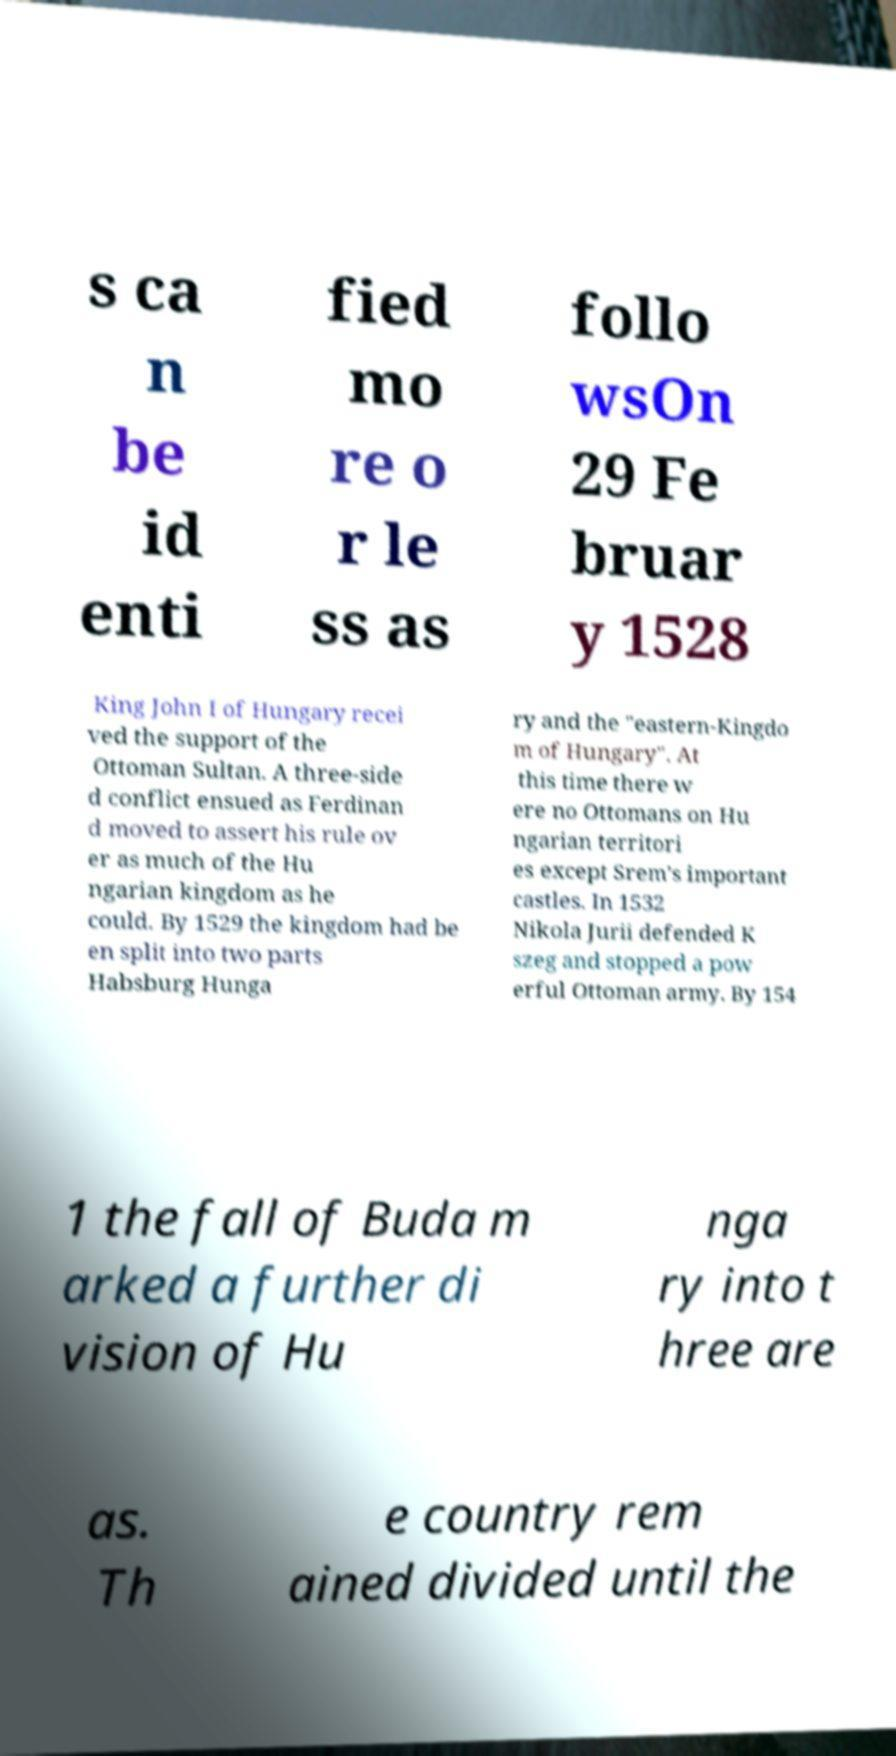Could you assist in decoding the text presented in this image and type it out clearly? s ca n be id enti fied mo re o r le ss as follo wsOn 29 Fe bruar y 1528 King John I of Hungary recei ved the support of the Ottoman Sultan. A three-side d conflict ensued as Ferdinan d moved to assert his rule ov er as much of the Hu ngarian kingdom as he could. By 1529 the kingdom had be en split into two parts Habsburg Hunga ry and the "eastern-Kingdo m of Hungary". At this time there w ere no Ottomans on Hu ngarian territori es except Srem's important castles. In 1532 Nikola Jurii defended K szeg and stopped a pow erful Ottoman army. By 154 1 the fall of Buda m arked a further di vision of Hu nga ry into t hree are as. Th e country rem ained divided until the 